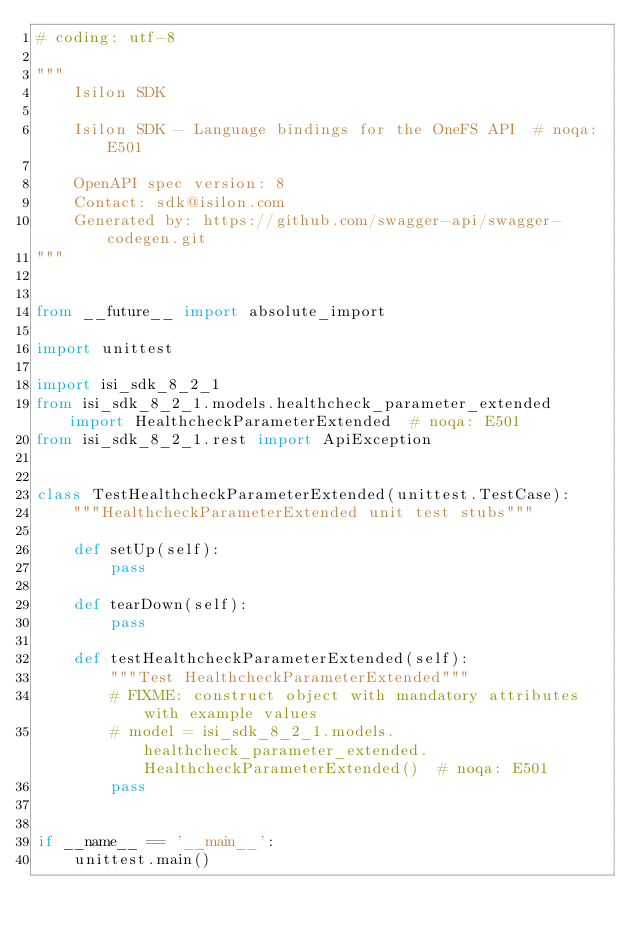Convert code to text. <code><loc_0><loc_0><loc_500><loc_500><_Python_># coding: utf-8

"""
    Isilon SDK

    Isilon SDK - Language bindings for the OneFS API  # noqa: E501

    OpenAPI spec version: 8
    Contact: sdk@isilon.com
    Generated by: https://github.com/swagger-api/swagger-codegen.git
"""


from __future__ import absolute_import

import unittest

import isi_sdk_8_2_1
from isi_sdk_8_2_1.models.healthcheck_parameter_extended import HealthcheckParameterExtended  # noqa: E501
from isi_sdk_8_2_1.rest import ApiException


class TestHealthcheckParameterExtended(unittest.TestCase):
    """HealthcheckParameterExtended unit test stubs"""

    def setUp(self):
        pass

    def tearDown(self):
        pass

    def testHealthcheckParameterExtended(self):
        """Test HealthcheckParameterExtended"""
        # FIXME: construct object with mandatory attributes with example values
        # model = isi_sdk_8_2_1.models.healthcheck_parameter_extended.HealthcheckParameterExtended()  # noqa: E501
        pass


if __name__ == '__main__':
    unittest.main()
</code> 